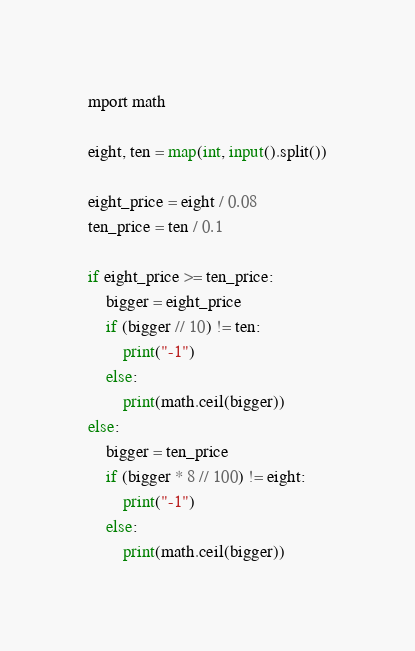<code> <loc_0><loc_0><loc_500><loc_500><_Python_>mport math

eight, ten = map(int, input().split())

eight_price = eight / 0.08
ten_price = ten / 0.1

if eight_price >= ten_price:
    bigger = eight_price
    if (bigger // 10) != ten:
        print("-1")
    else:
        print(math.ceil(bigger))
else:
    bigger = ten_price
    if (bigger * 8 // 100) != eight:
        print("-1")
    else:
        print(math.ceil(bigger))</code> 